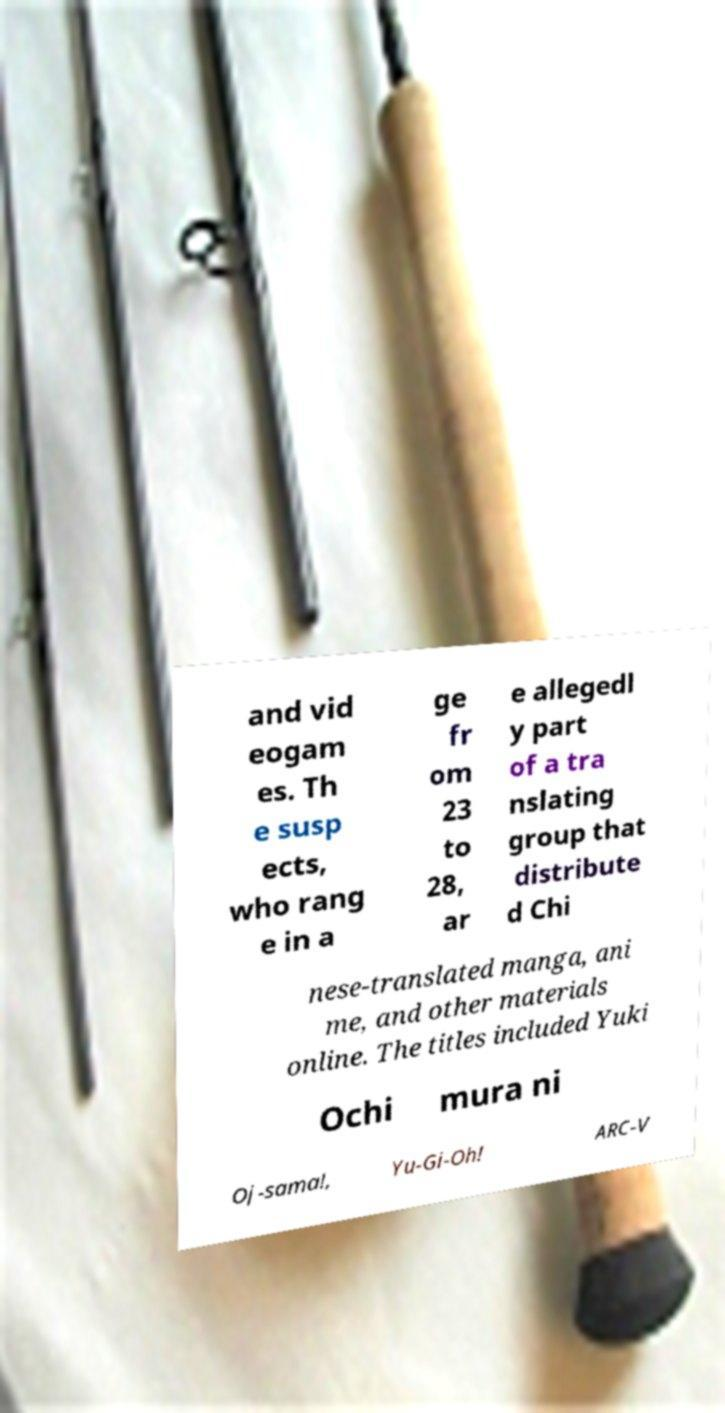Could you extract and type out the text from this image? and vid eogam es. Th e susp ects, who rang e in a ge fr om 23 to 28, ar e allegedl y part of a tra nslating group that distribute d Chi nese-translated manga, ani me, and other materials online. The titles included Yuki Ochi mura ni Oj-sama!, Yu-Gi-Oh! ARC-V 